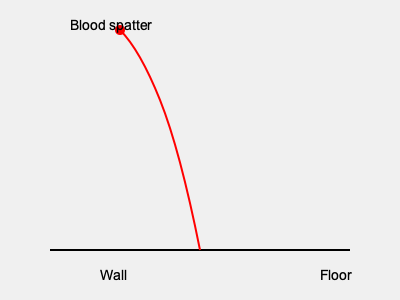Based on the blood spatter pattern shown in the diagram, what can you determine about the angle of impact and the likely position of the victim during the crime? 1. Analyze the shape of the blood spatter:
   - The elongated, teardrop shape of the spatter indicates a non-perpendicular angle of impact.
   - The direction of the tail points towards the origin of the blood.

2. Calculate the angle of impact:
   - Use the formula: $\sin \theta = \frac{width}{length}$
   - Estimate the width and length of a typical blood drop in the pattern.
   - Let's say width ≈ 2 mm and length ≈ 6 mm
   - $\sin \theta = \frac{2}{6} = \frac{1}{3}$
   - $\theta = \arcsin(\frac{1}{3}) \approx 19.5°$

3. Determine the origin of the blood:
   - The spatter pattern curves upward from right to left.
   - This suggests the blood originated from a lower position on the right.

4. Interpret the findings:
   - The low angle of impact (approximately 19.5°) indicates the blood source was close to the ground.
   - The upward curve of the pattern suggests the victim was likely on the floor or in a low position when the injury occurred.

5. Consider the crime scenario:
   - The victim was probably lying on the floor or crouching when they were struck.
   - The attacker was likely standing over or near the victim, causing blood to spatter upward and to the left on the wall.
Answer: The victim was likely on the floor or in a low position, with blood originating from a low angle (≈19.5°) and moving upward to the left. 